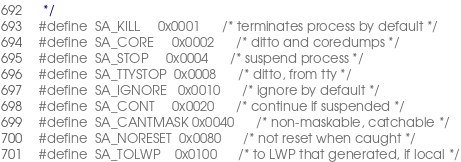Convert code to text. <code><loc_0><loc_0><loc_500><loc_500><_C_> */
#define	SA_KILL		0x0001		/* terminates process by default */
#define	SA_CORE		0x0002		/* ditto and coredumps */
#define	SA_STOP		0x0004		/* suspend process */
#define	SA_TTYSTOP	0x0008		/* ditto, from tty */
#define	SA_IGNORE	0x0010		/* ignore by default */
#define	SA_CONT		0x0020		/* continue if suspended */
#define	SA_CANTMASK	0x0040		/* non-maskable, catchable */
#define	SA_NORESET	0x0080		/* not reset when caught */
#define	SA_TOLWP	0x0100		/* to LWP that generated, if local */</code> 